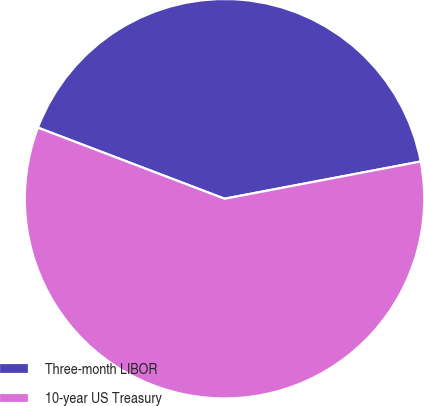Convert chart to OTSL. <chart><loc_0><loc_0><loc_500><loc_500><pie_chart><fcel>Three-month LIBOR<fcel>10-year US Treasury<nl><fcel>41.22%<fcel>58.78%<nl></chart> 